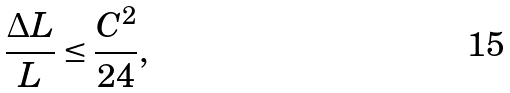Convert formula to latex. <formula><loc_0><loc_0><loc_500><loc_500>\frac { \Delta L } { L } \leq \frac { C ^ { 2 } } { 2 4 } ,</formula> 